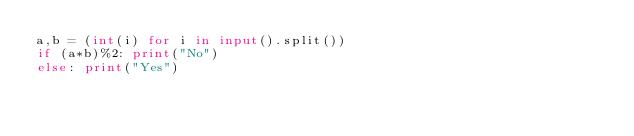<code> <loc_0><loc_0><loc_500><loc_500><_Python_>a,b = (int(i) for i in input().split())
if (a*b)%2: print("No")
else: print("Yes")</code> 